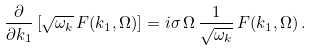<formula> <loc_0><loc_0><loc_500><loc_500>\frac { \partial } { \partial k _ { 1 } } \left [ \sqrt { \omega _ { k } } \, F ( k _ { 1 } , \Omega ) \right ] = i \sigma \, \Omega \, \frac { 1 } { \sqrt { \omega _ { k } } } \, F ( k _ { 1 } , \Omega ) \, .</formula> 